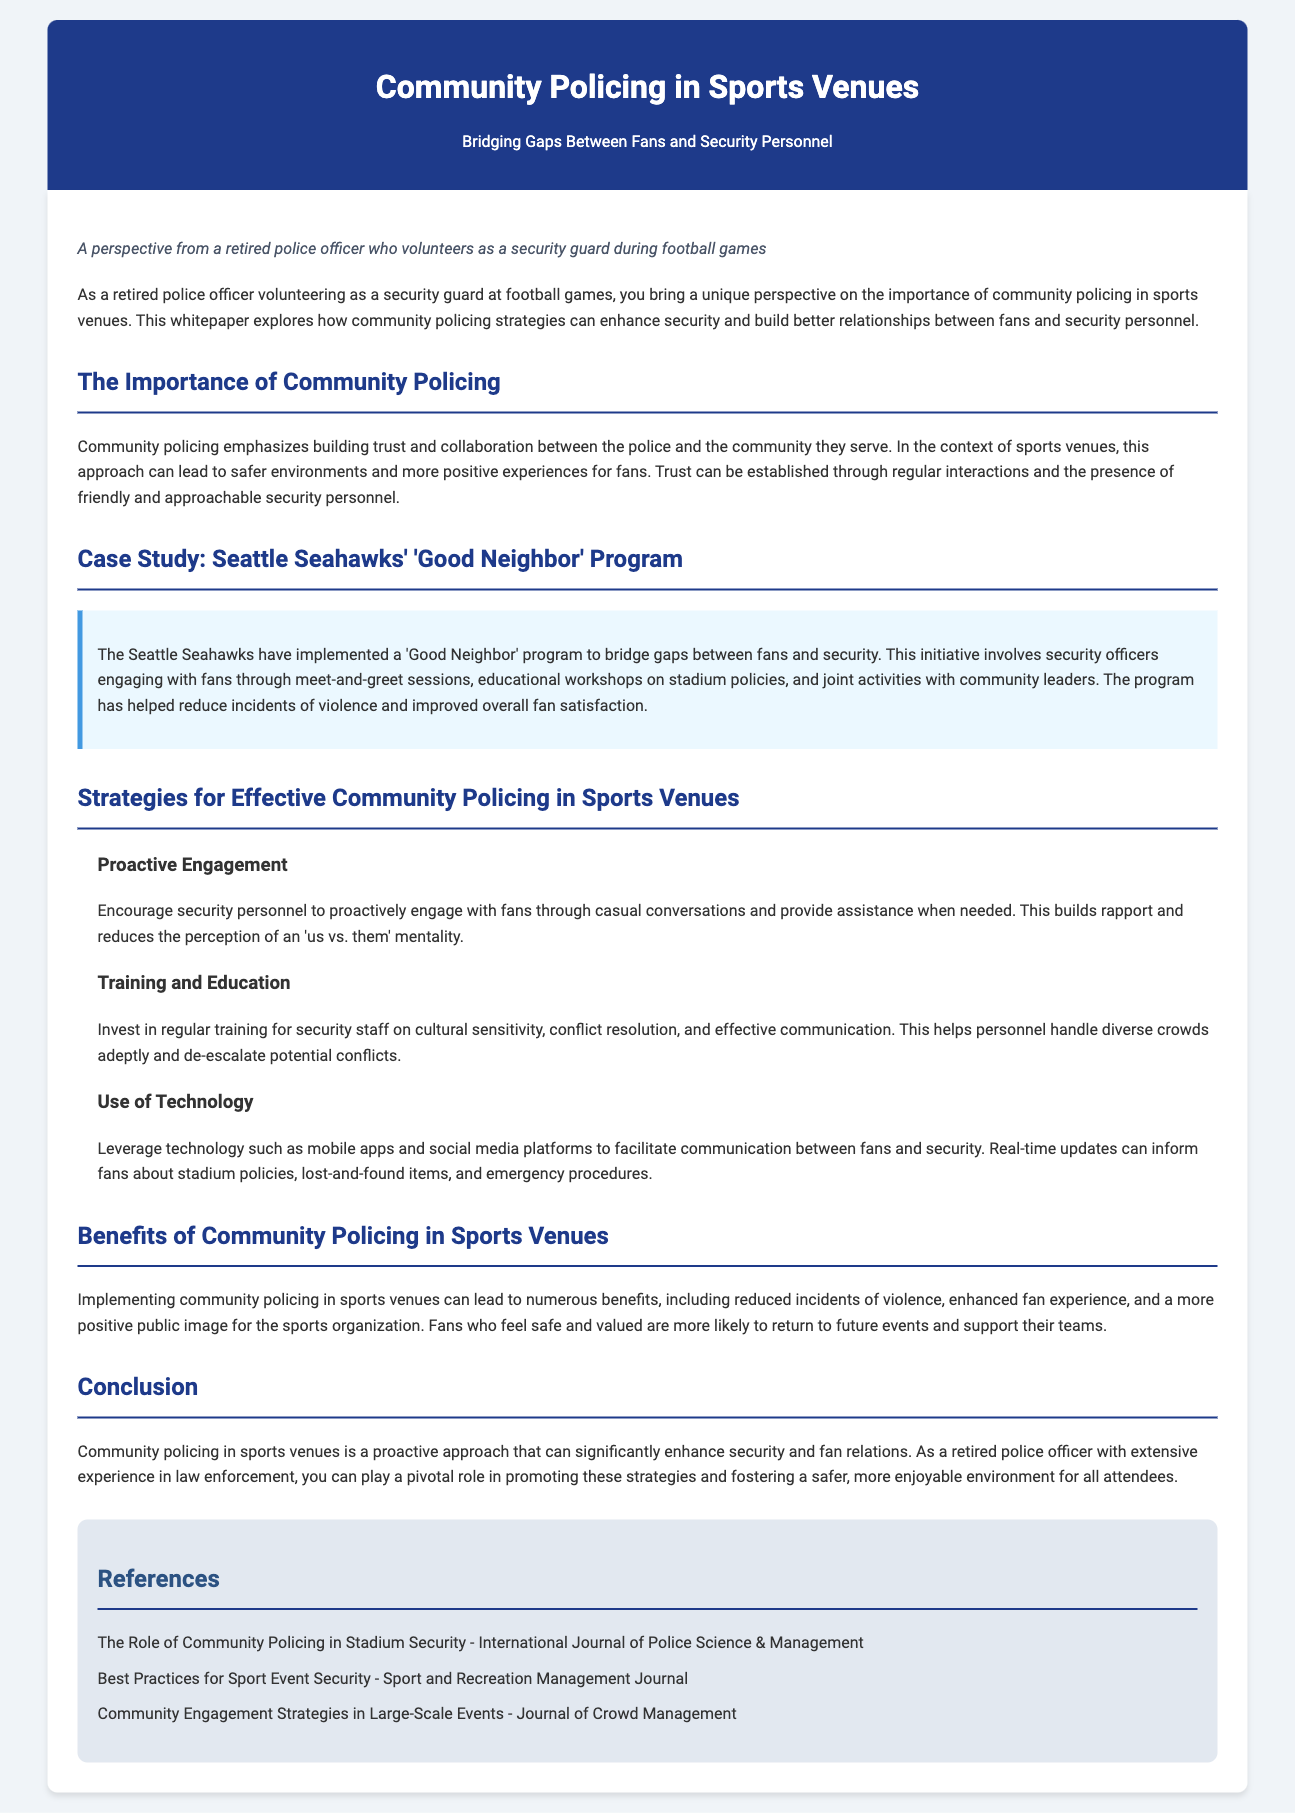What is the title of the whitepaper? The title of the whitepaper is indicated in the header, which emphasizes community policing and the specific context of sports venues.
Answer: Community Policing in Sports Venues What program is highlighted as a case study? The case study discussed in the whitepaper focuses on a specific initiative by a sports team, showcasing effective community engagement.
Answer: 'Good Neighbor' Program What main benefit is mentioned regarding community policing? The document outlines several advantages of this approach, specifically focusing on its positive impact on safety and fan experience.
Answer: Reduced incidents of violence What is one strategy for effective community policing discussed? The whitepaper provides various strategies, one of which emphasizes proactive involvement from security personnel.
Answer: Proactive Engagement What type of training is emphasized for security staff? The document recommends specific training areas to improve personnel interactions and conflict resolution skills.
Answer: Cultural sensitivity How can technology be utilized according to the whitepaper? The whitepaper suggests a modern means of improving communication between fans and security, indicating a preference for specific technology tools.
Answer: Mobile apps and social media platforms What is the conclusion about community policing in sports venues? The conclusion summarizes the overall benefits and importance of implementing community policing strategies in these settings.
Answer: Enhances security and fan relations Who is the intended audience of the whitepaper? The whitepaper is crafted from a particular viewpoint, indicating who might find the discussion most relevant or insightful.
Answer: Retired police officers volunteering as security guards 